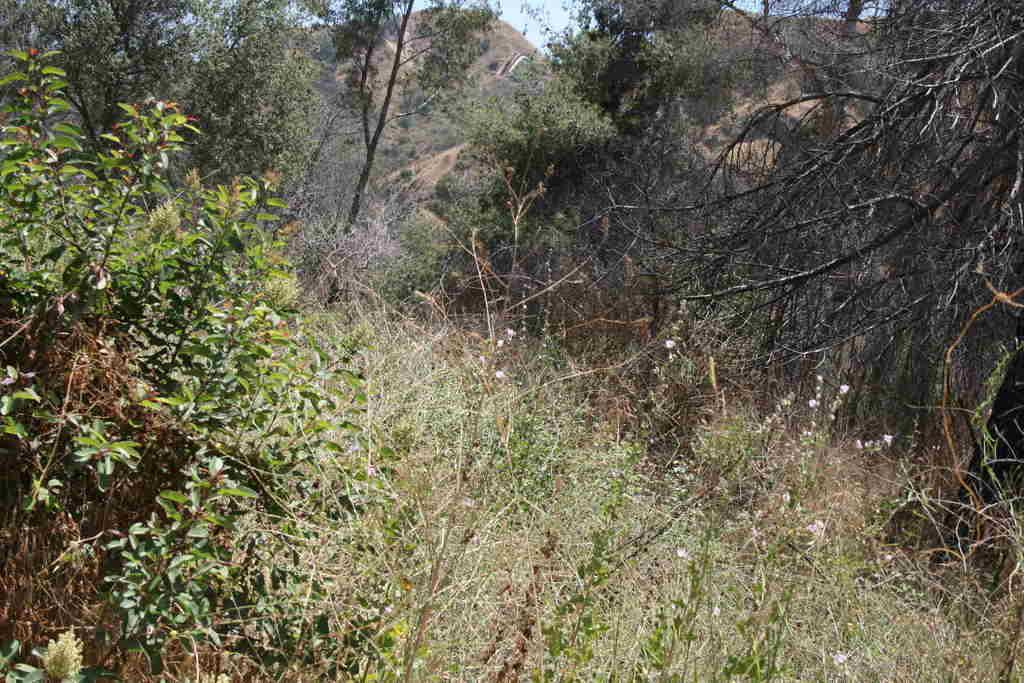What type of vegetation is present in the image? There are many trees and plants in the image. Can you describe the landscape in the image? The image features hills visible in the background. What hobbies are the trees participating in within the image? Trees do not have hobbies, as they are inanimate objects. Can you see a spade being used by the plants in the image? There is no spade present in the image. 